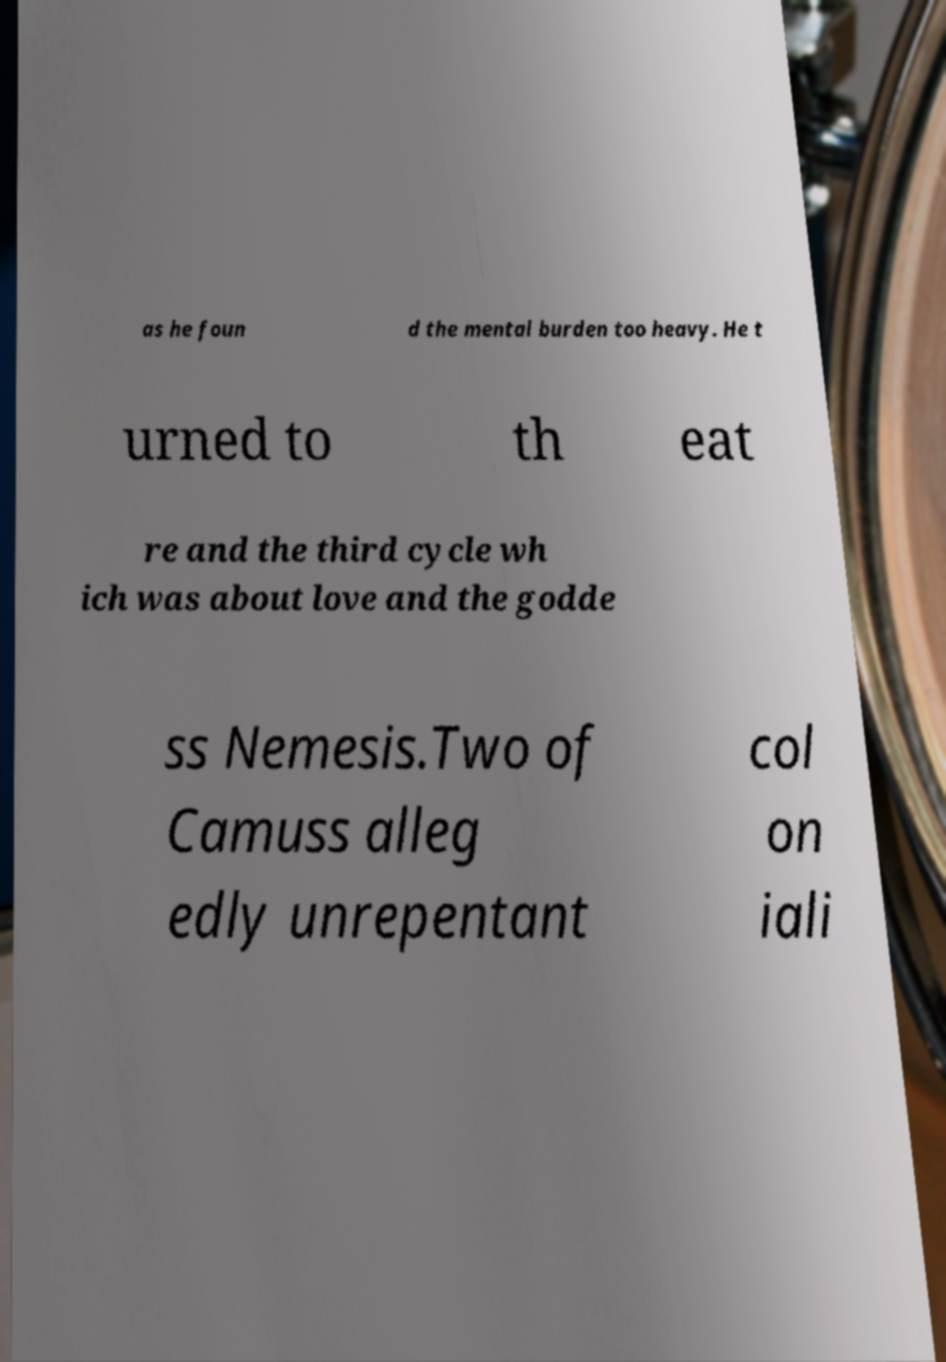Could you assist in decoding the text presented in this image and type it out clearly? as he foun d the mental burden too heavy. He t urned to th eat re and the third cycle wh ich was about love and the godde ss Nemesis.Two of Camuss alleg edly unrepentant col on iali 